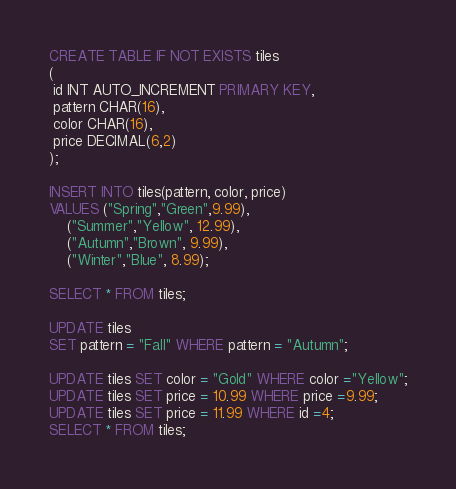<code> <loc_0><loc_0><loc_500><loc_500><_SQL_>CREATE TABLE IF NOT EXISTS tiles
(
 id INT AUTO_INCREMENT PRIMARY KEY,
 pattern CHAR(16),
 color CHAR(16),
 price DECIMAL(6,2)
);

INSERT INTO tiles(pattern, color, price)
VALUES ("Spring","Green",9.99),
	("Summer","Yellow", 12.99),
	("Autumn","Brown", 9.99),
	("Winter","Blue", 8.99);

SELECT * FROM tiles;

UPDATE tiles
SET pattern = "Fall" WHERE pattern = "Autumn";

UPDATE tiles SET color = "Gold" WHERE color ="Yellow";
UPDATE tiles SET price = 10.99 WHERE price =9.99;
UPDATE tiles SET price = 11.99 WHERE id =4;
SELECT * FROM tiles;</code> 